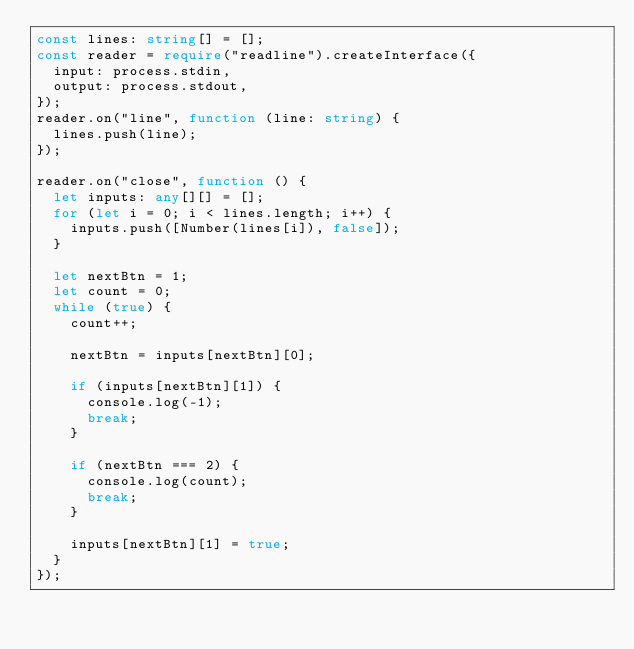<code> <loc_0><loc_0><loc_500><loc_500><_TypeScript_>const lines: string[] = [];
const reader = require("readline").createInterface({
  input: process.stdin,
  output: process.stdout,
});
reader.on("line", function (line: string) {
  lines.push(line);
});

reader.on("close", function () {
  let inputs: any[][] = [];
  for (let i = 0; i < lines.length; i++) {
    inputs.push([Number(lines[i]), false]);
  }

  let nextBtn = 1;
  let count = 0;
  while (true) {
    count++;

    nextBtn = inputs[nextBtn][0];

    if (inputs[nextBtn][1]) {
      console.log(-1);
      break;
    }

    if (nextBtn === 2) {
      console.log(count);
      break;
    }

    inputs[nextBtn][1] = true;
  }
});
</code> 